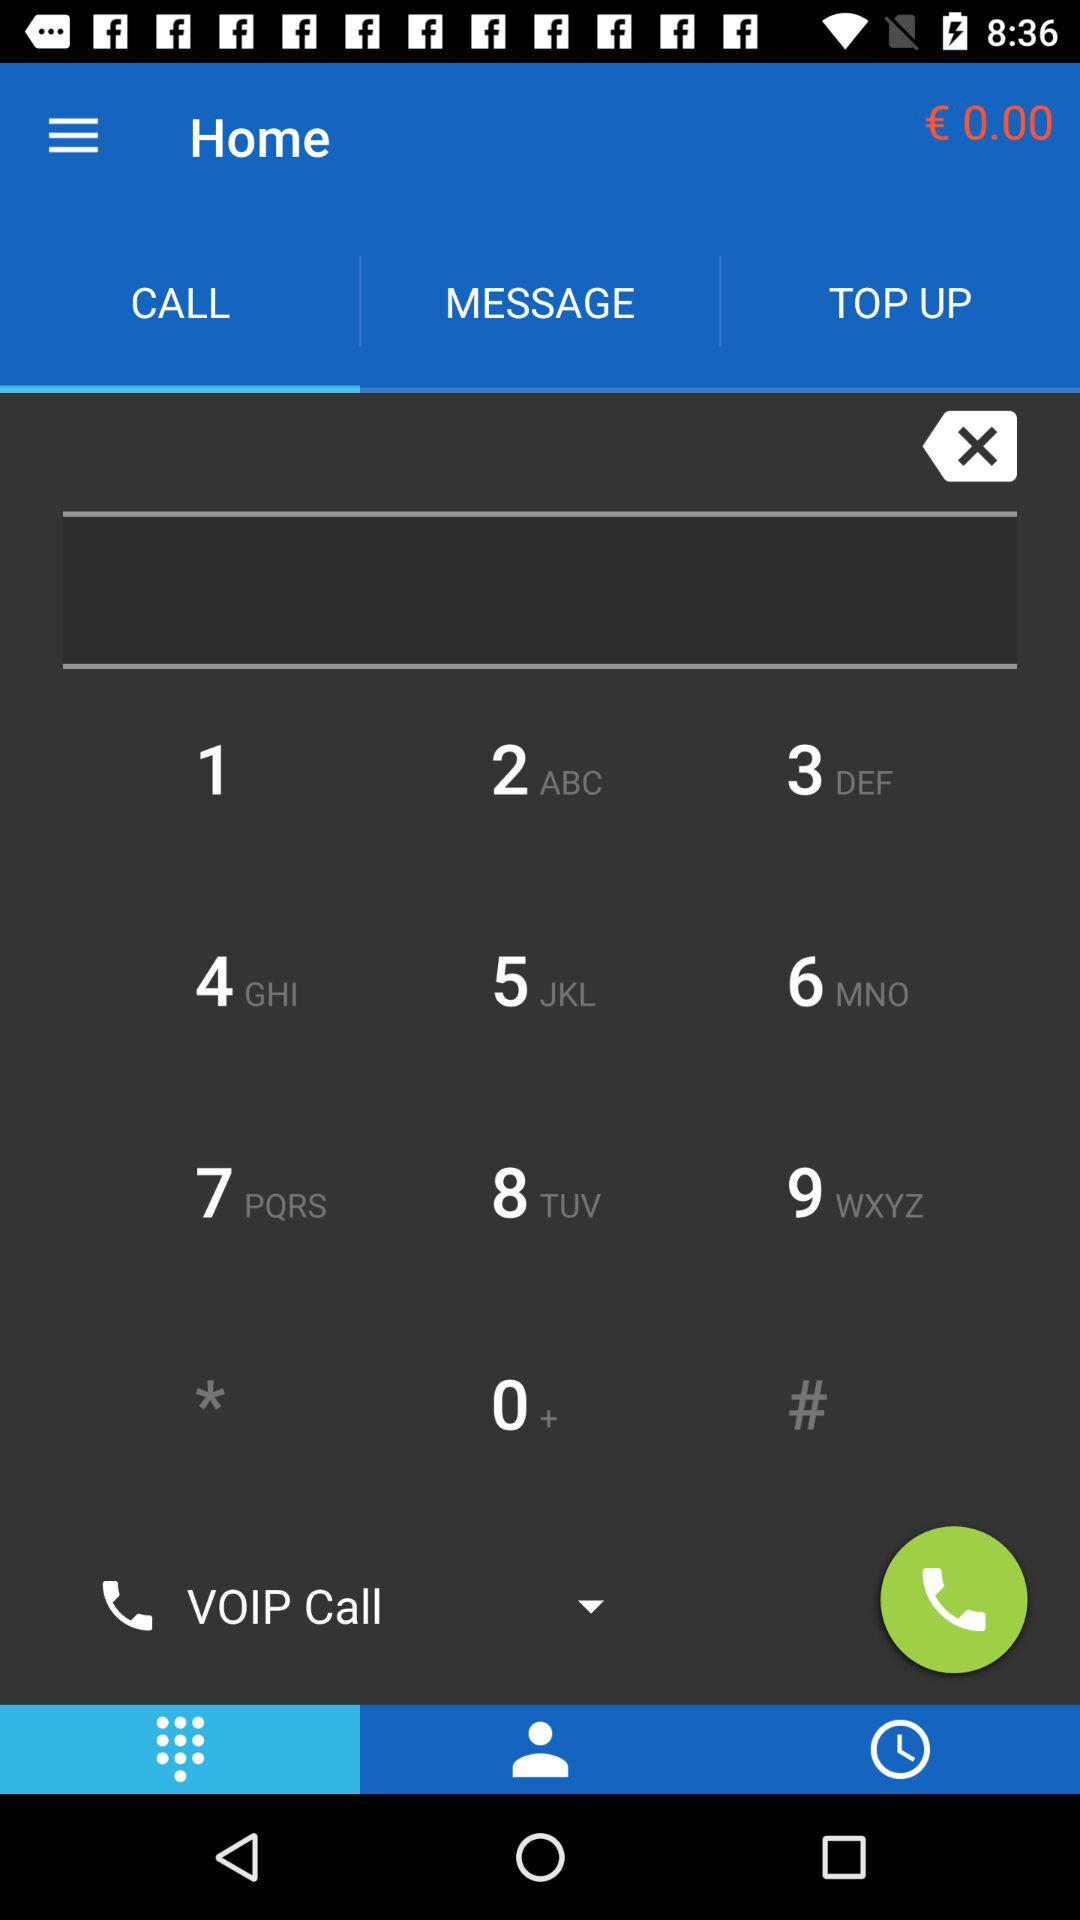What is the selected call type? The selected call type is "VOIP Call". 